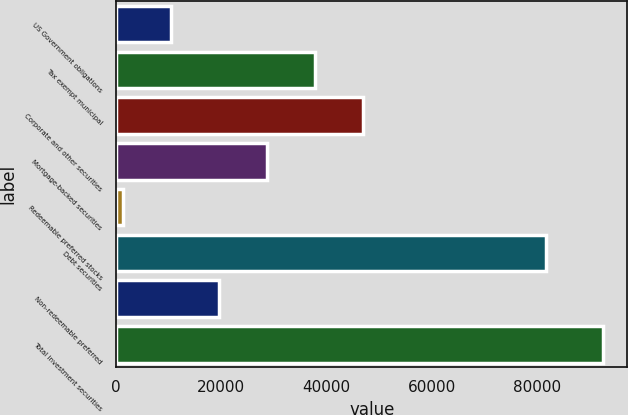<chart> <loc_0><loc_0><loc_500><loc_500><bar_chart><fcel>US Government obligations<fcel>Tax exempt municipal<fcel>Corporate and other securities<fcel>Mortgage-backed securities<fcel>Redeemable preferred stocks<fcel>Debt securities<fcel>Non-redeemable preferred<fcel>Total investment securities<nl><fcel>10368.9<fcel>37761.6<fcel>46892.5<fcel>28630.7<fcel>1238<fcel>81758<fcel>19499.8<fcel>92547<nl></chart> 